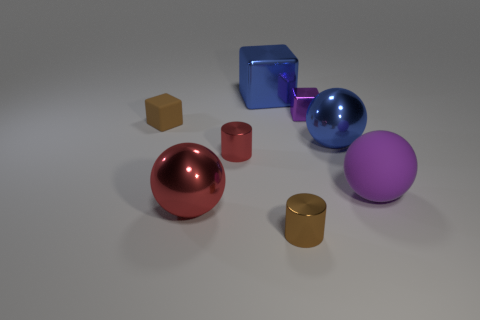Add 1 big blue metallic objects. How many objects exist? 9 Subtract all big shiny balls. How many balls are left? 1 Subtract 1 spheres. How many spheres are left? 2 Subtract all cylinders. How many objects are left? 6 Subtract all yellow spheres. Subtract all green cylinders. How many spheres are left? 3 Subtract all large red rubber cubes. Subtract all big blue objects. How many objects are left? 6 Add 6 brown cylinders. How many brown cylinders are left? 7 Add 5 big metal spheres. How many big metal spheres exist? 7 Subtract 1 red cylinders. How many objects are left? 7 